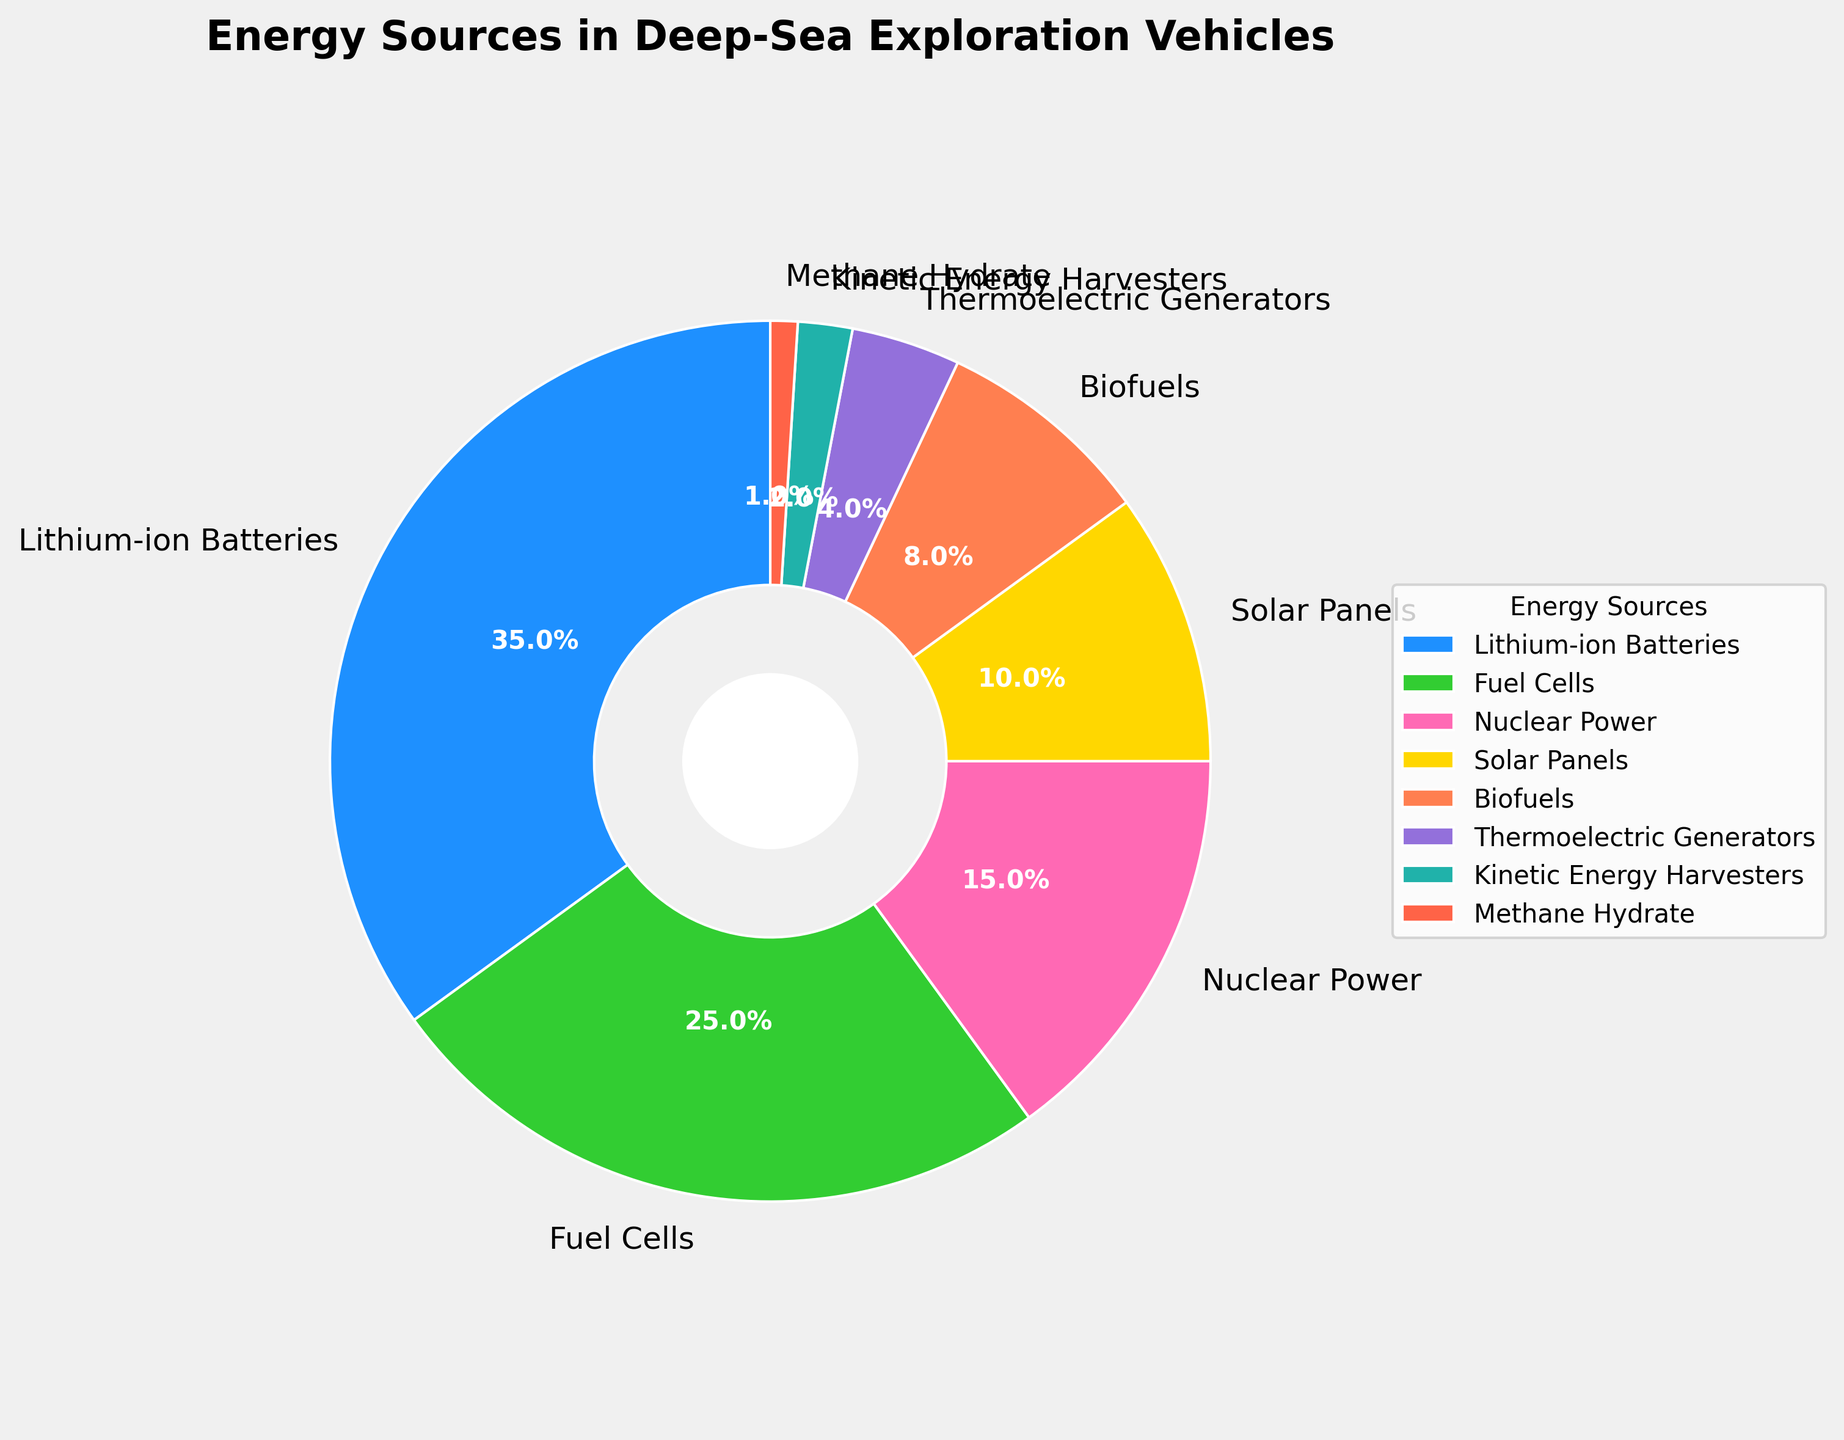What is the most frequently used energy source in deep-sea exploration vehicles? The largest segment of the pie chart represents the most frequently used energy source. Lithium-ion Batteries occupy the largest portion of the pie chart.
Answer: Lithium-ion Batteries Which energy source covers the smallest percentage in the pie chart? The smallest segment of the pie chart represents the least frequently used energy source. Methane Hydrate covers only 1% of the chart based on its smallest slice.
Answer: Methane Hydrate What is the combined percentage of Fuel Cells and Nuclear Power? Adding the percentages of Fuel Cells (25%) and Nuclear Power (15%) gives the total combined percentage. 25 + 15 = 40
Answer: 40% Which energy source contributes more, Solar Panels or Biofuels? Comparing the sizes of the Solar Panels (10%) and Biofuels (8%) sections, Solar Panels have a larger percentage.
Answer: Solar Panels How many energy sources contribute less than 10%? Observing the pie chart, the energy sources with percentages below 10% are Solar Panels (10%), Biofuels (8%), Thermoelectric Generators (4%), Kinetic Energy Harvesters (2%), and Methane Hydrate (1%). There are five such sources.
Answer: 5 What is the difference in percentage between Lithium-ion Batteries and Thermoelectric Generators? Subtracting the percentage of Thermoelectric Generators (4%) from the percentage of Lithium-ion Batteries (35%) gives the difference. 35 - 4 = 31
Answer: 31% Which energy source is represented by the dark blue segment? The color dark blue corresponds to the largest segment, which represents Lithium-ion Batteries.
Answer: Lithium-ion Batteries Arrange the energy sources in descending order of their usage percentages. Sorting the energy sources by their percentages: Lithium-ion Batteries (35%), Fuel Cells (25%), Nuclear Power (15%), Solar Panels (10%), Biofuels (8%), Thermoelectric Generators (4%), Kinetic Energy Harvesters (2%), Methane Hydrate (1%).
Answer: Lithium-ion Batteries, Fuel Cells, Nuclear Power, Solar Panels, Biofuels, Thermoelectric Generators, Kinetic Energy Harvesters, Methane Hydrate What is the sum of the percentages for non-renewable energy sources (Lithium-ion Batteries, Nuclear Power, Methane Hydrate)? Adding the percentages of non-renewable sources: Lithium-ion Batteries (35%), Nuclear Power (15%), Methane Hydrate (1%). 35 + 15 + 1 = 51
Answer: 51% 